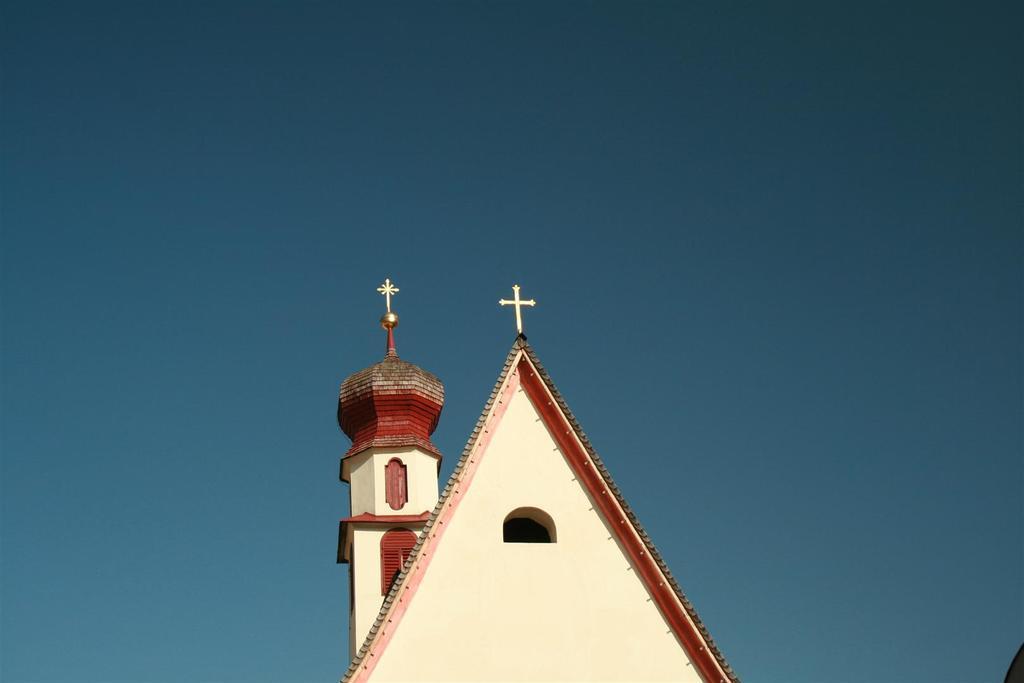Can you describe this image briefly? In this image we can see the top view of the church. In the background we can see the sky. 